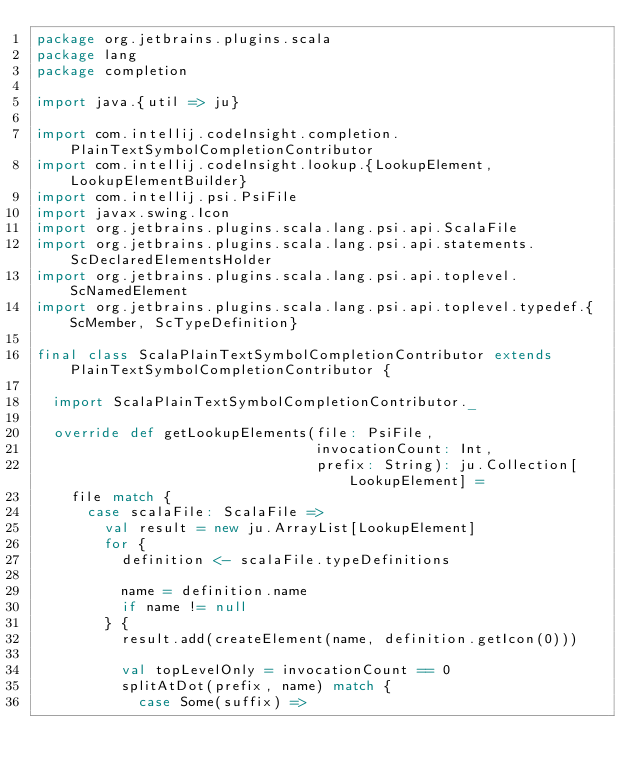<code> <loc_0><loc_0><loc_500><loc_500><_Scala_>package org.jetbrains.plugins.scala
package lang
package completion

import java.{util => ju}

import com.intellij.codeInsight.completion.PlainTextSymbolCompletionContributor
import com.intellij.codeInsight.lookup.{LookupElement, LookupElementBuilder}
import com.intellij.psi.PsiFile
import javax.swing.Icon
import org.jetbrains.plugins.scala.lang.psi.api.ScalaFile
import org.jetbrains.plugins.scala.lang.psi.api.statements.ScDeclaredElementsHolder
import org.jetbrains.plugins.scala.lang.psi.api.toplevel.ScNamedElement
import org.jetbrains.plugins.scala.lang.psi.api.toplevel.typedef.{ScMember, ScTypeDefinition}

final class ScalaPlainTextSymbolCompletionContributor extends PlainTextSymbolCompletionContributor {

  import ScalaPlainTextSymbolCompletionContributor._

  override def getLookupElements(file: PsiFile,
                                 invocationCount: Int,
                                 prefix: String): ju.Collection[LookupElement] =
    file match {
      case scalaFile: ScalaFile =>
        val result = new ju.ArrayList[LookupElement]
        for {
          definition <- scalaFile.typeDefinitions

          name = definition.name
          if name != null
        } {
          result.add(createElement(name, definition.getIcon(0)))

          val topLevelOnly = invocationCount == 0
          splitAtDot(prefix, name) match {
            case Some(suffix) =></code> 